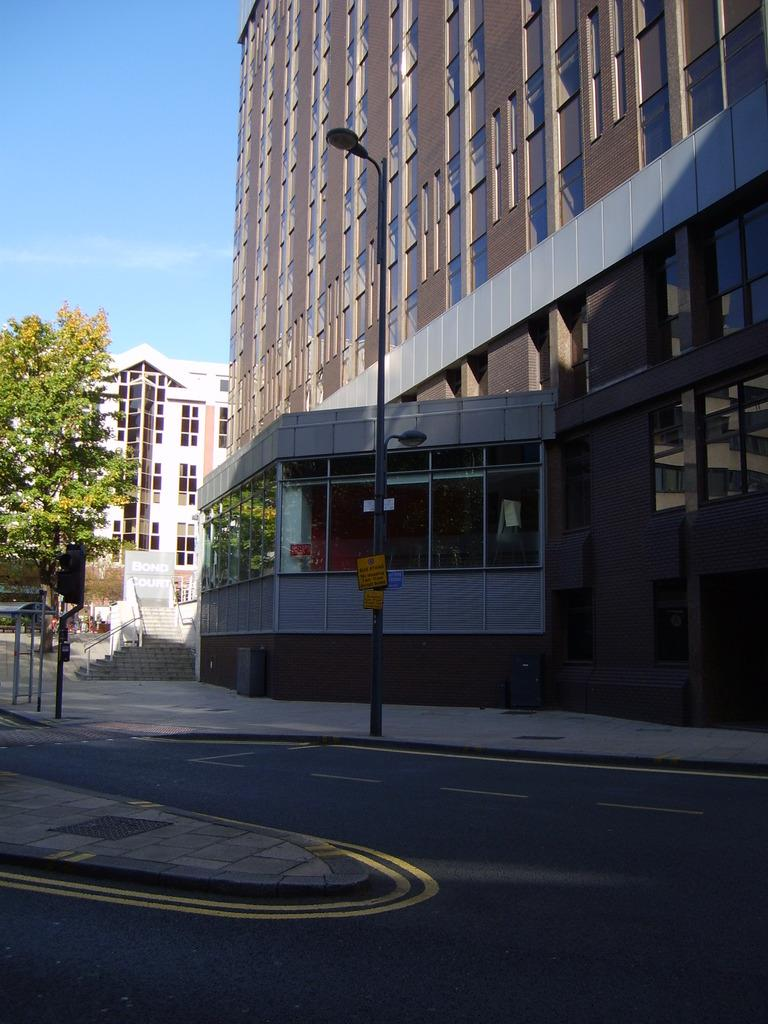What type of pathway is visible in the image? There is a road in the image. What structures can be seen alongside the road? There are street light poles on the ground. What type of man-made structures are present in the image? There are buildings in the image. What is the condition of the sky in the image? The sky is clear in the image. What type of substance is being polished by the street light poles in the image? There is no substance being polished by the street light poles in the image. Can you tell me how many hooks are attached to the buildings in the image? There is no mention of hooks on the buildings in the image. 